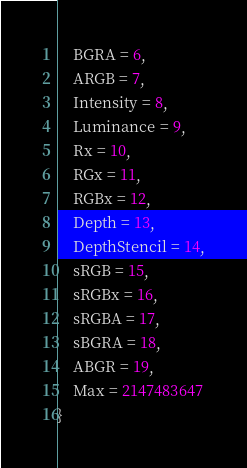<code> <loc_0><loc_0><loc_500><loc_500><_TypeScript_>    BGRA = 6,
    ARGB = 7,
    Intensity = 8,
    Luminance = 9,
    Rx = 10,
    RGx = 11,
    RGBx = 12,
    Depth = 13,
    DepthStencil = 14,
    sRGB = 15,
    sRGBx = 16,
    sRGBA = 17,
    sBGRA = 18,
    ABGR = 19,
    Max = 2147483647
}
</code> 